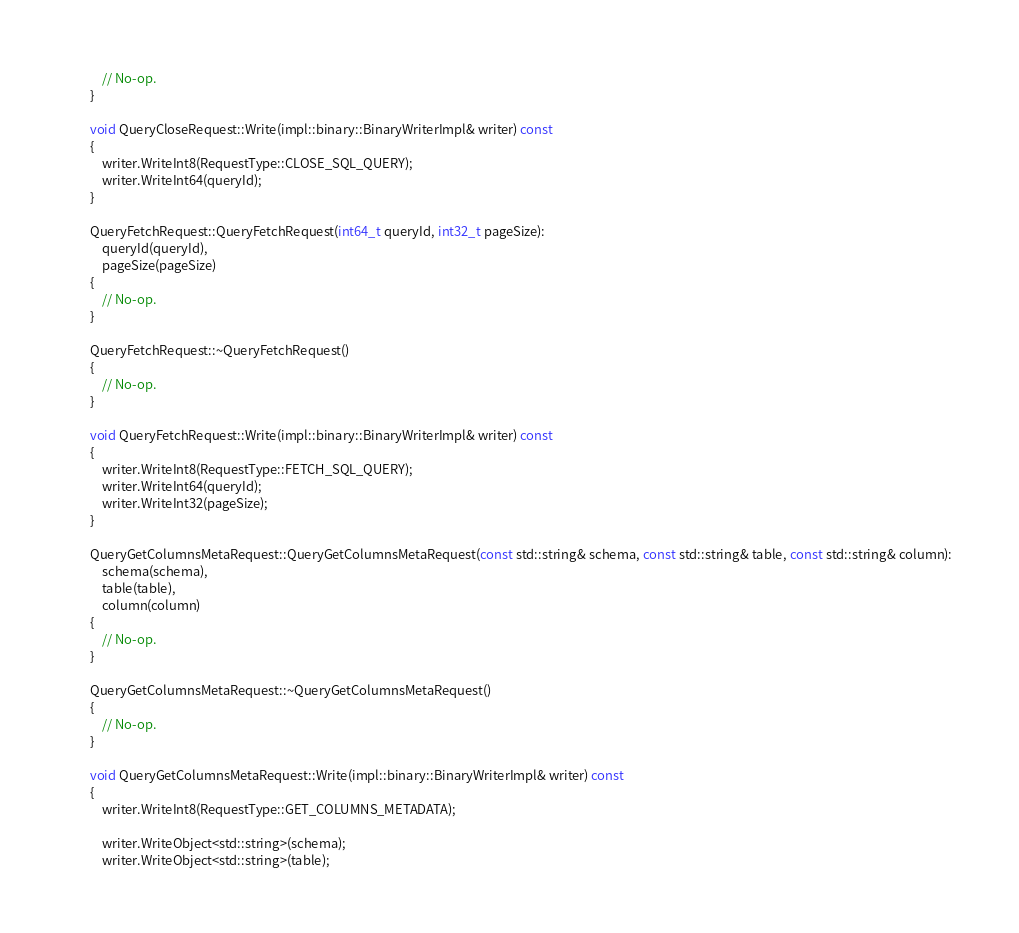<code> <loc_0><loc_0><loc_500><loc_500><_C++_>            // No-op.
        }

        void QueryCloseRequest::Write(impl::binary::BinaryWriterImpl& writer) const
        {
            writer.WriteInt8(RequestType::CLOSE_SQL_QUERY);
            writer.WriteInt64(queryId);
        }

        QueryFetchRequest::QueryFetchRequest(int64_t queryId, int32_t pageSize):
            queryId(queryId),
            pageSize(pageSize)
        {
            // No-op.
        }

        QueryFetchRequest::~QueryFetchRequest()
        {
            // No-op.
        }

        void QueryFetchRequest::Write(impl::binary::BinaryWriterImpl& writer) const
        {
            writer.WriteInt8(RequestType::FETCH_SQL_QUERY);
            writer.WriteInt64(queryId);
            writer.WriteInt32(pageSize);
        }

        QueryGetColumnsMetaRequest::QueryGetColumnsMetaRequest(const std::string& schema, const std::string& table, const std::string& column):
            schema(schema),
            table(table),
            column(column)
        {
            // No-op.
        }

        QueryGetColumnsMetaRequest::~QueryGetColumnsMetaRequest()
        {
            // No-op.
        }

        void QueryGetColumnsMetaRequest::Write(impl::binary::BinaryWriterImpl& writer) const
        {
            writer.WriteInt8(RequestType::GET_COLUMNS_METADATA);

            writer.WriteObject<std::string>(schema);
            writer.WriteObject<std::string>(table);</code> 